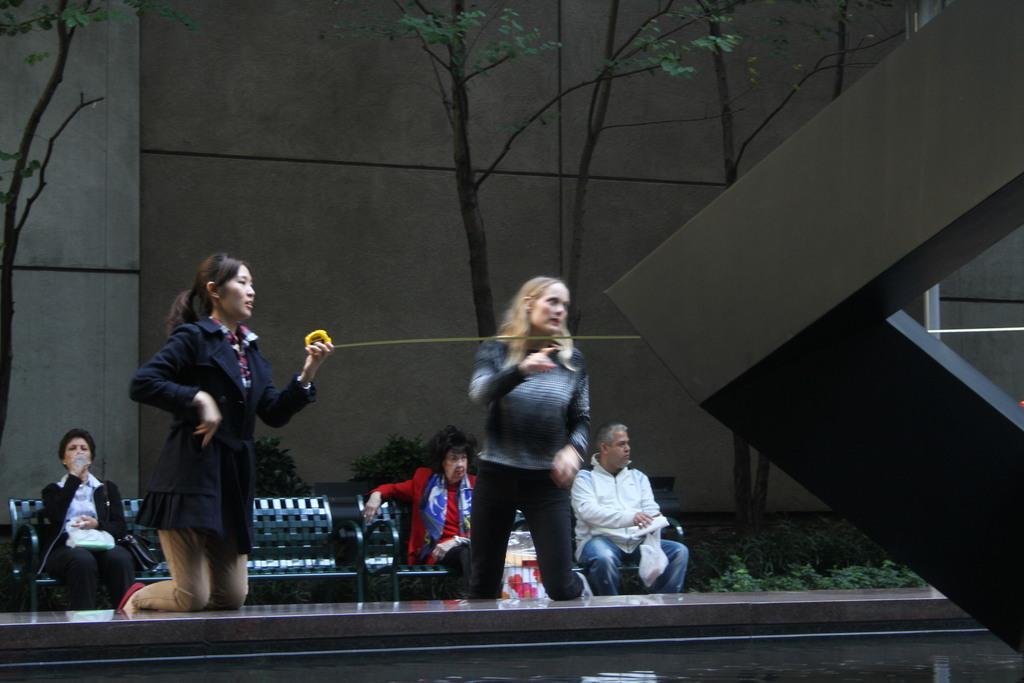Please provide a concise description of this image. In this image I can see two women are sitting on the knees and looking towards the right side. At the back three people are sitting on a bench and there are some plants. In the background, I can see a wall and trees. 